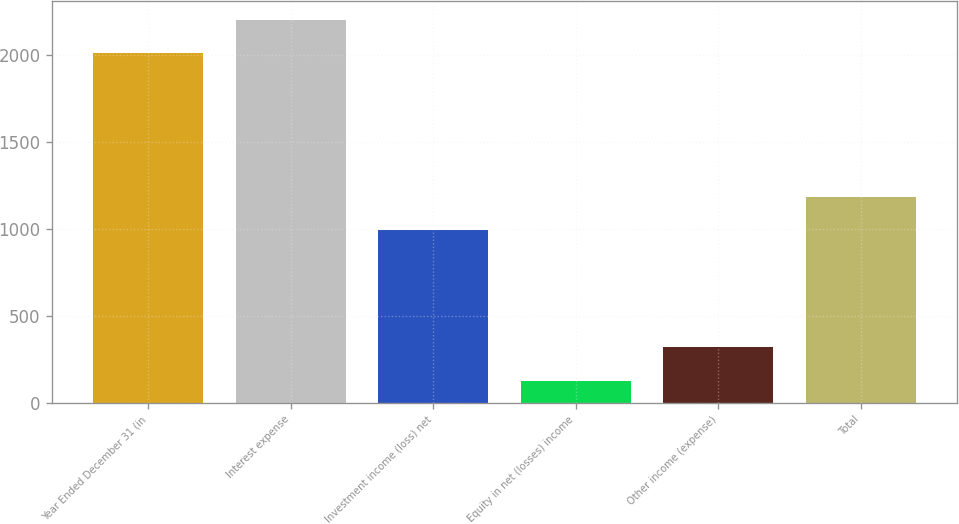Convert chart to OTSL. <chart><loc_0><loc_0><loc_500><loc_500><bar_chart><fcel>Year Ended December 31 (in<fcel>Interest expense<fcel>Investment income (loss) net<fcel>Equity in net (losses) income<fcel>Other income (expense)<fcel>Total<nl><fcel>2006<fcel>2200<fcel>990<fcel>124<fcel>318<fcel>1184<nl></chart> 